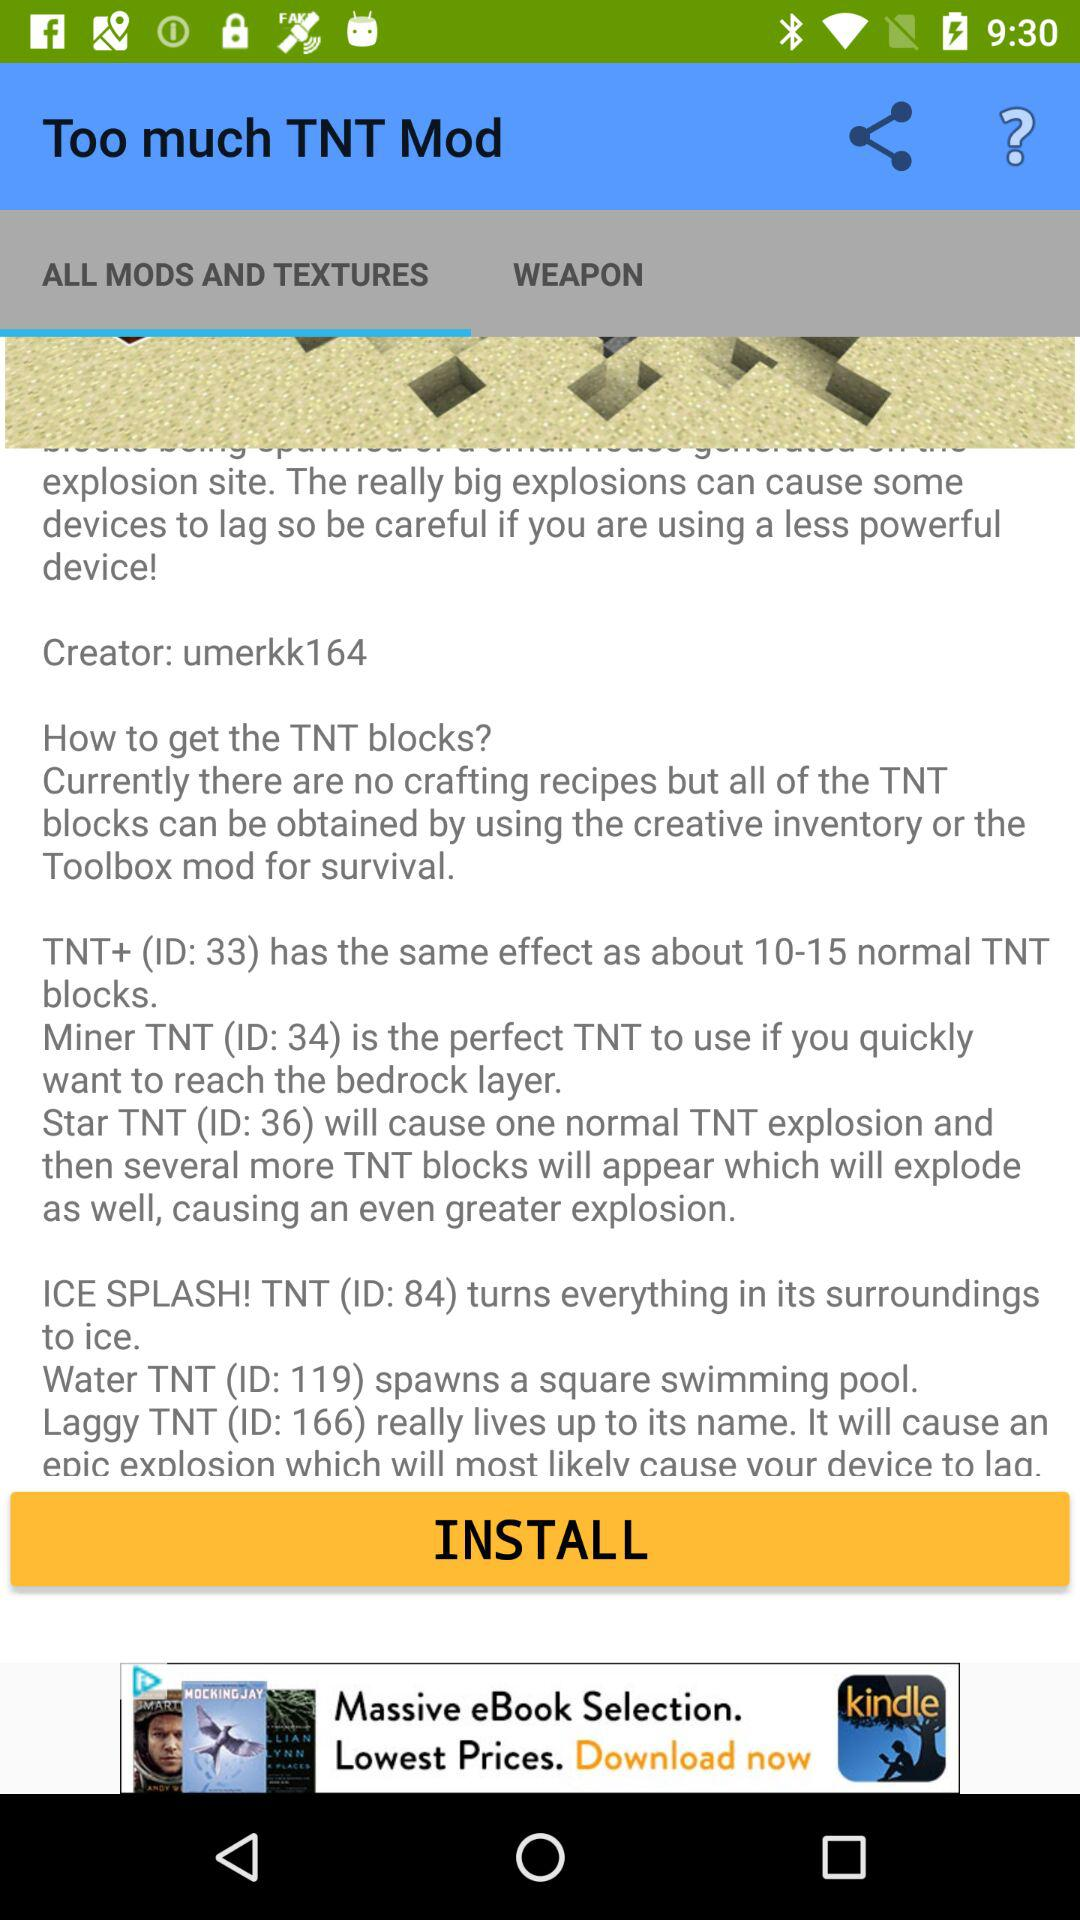What is the app name? The app name is "Too much TNT Mod". 